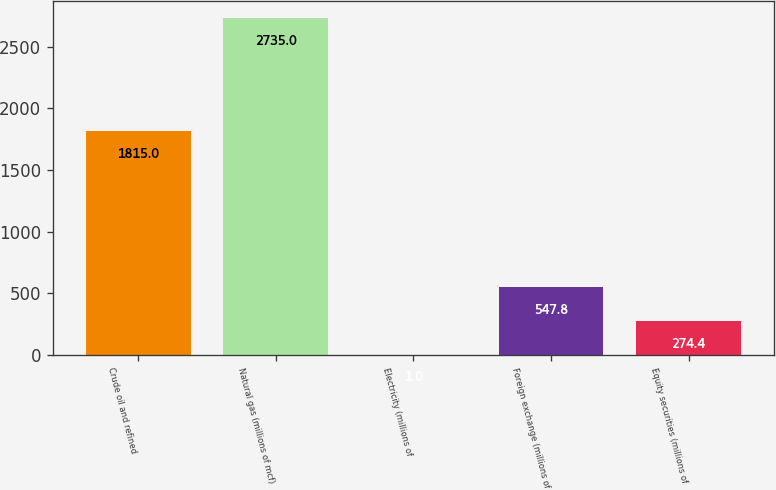<chart> <loc_0><loc_0><loc_500><loc_500><bar_chart><fcel>Crude oil and refined<fcel>Natural gas (millions of mcf)<fcel>Electricity (millions of<fcel>Foreign exchange (millions of<fcel>Equity securities (millions of<nl><fcel>1815<fcel>2735<fcel>1<fcel>547.8<fcel>274.4<nl></chart> 